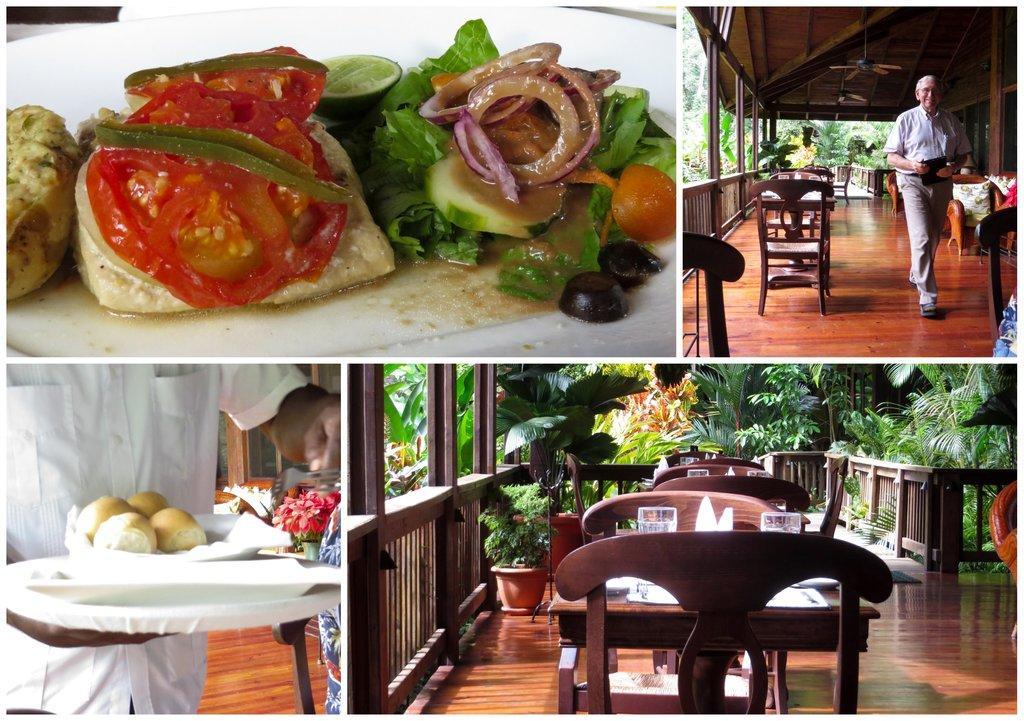Describe this image in one or two sentences. In this image i can see a food item on the plate, a man walking and a man holding a plate with food items in it and few empty chairs in front of a table. In the background i can see trees and a railing. 